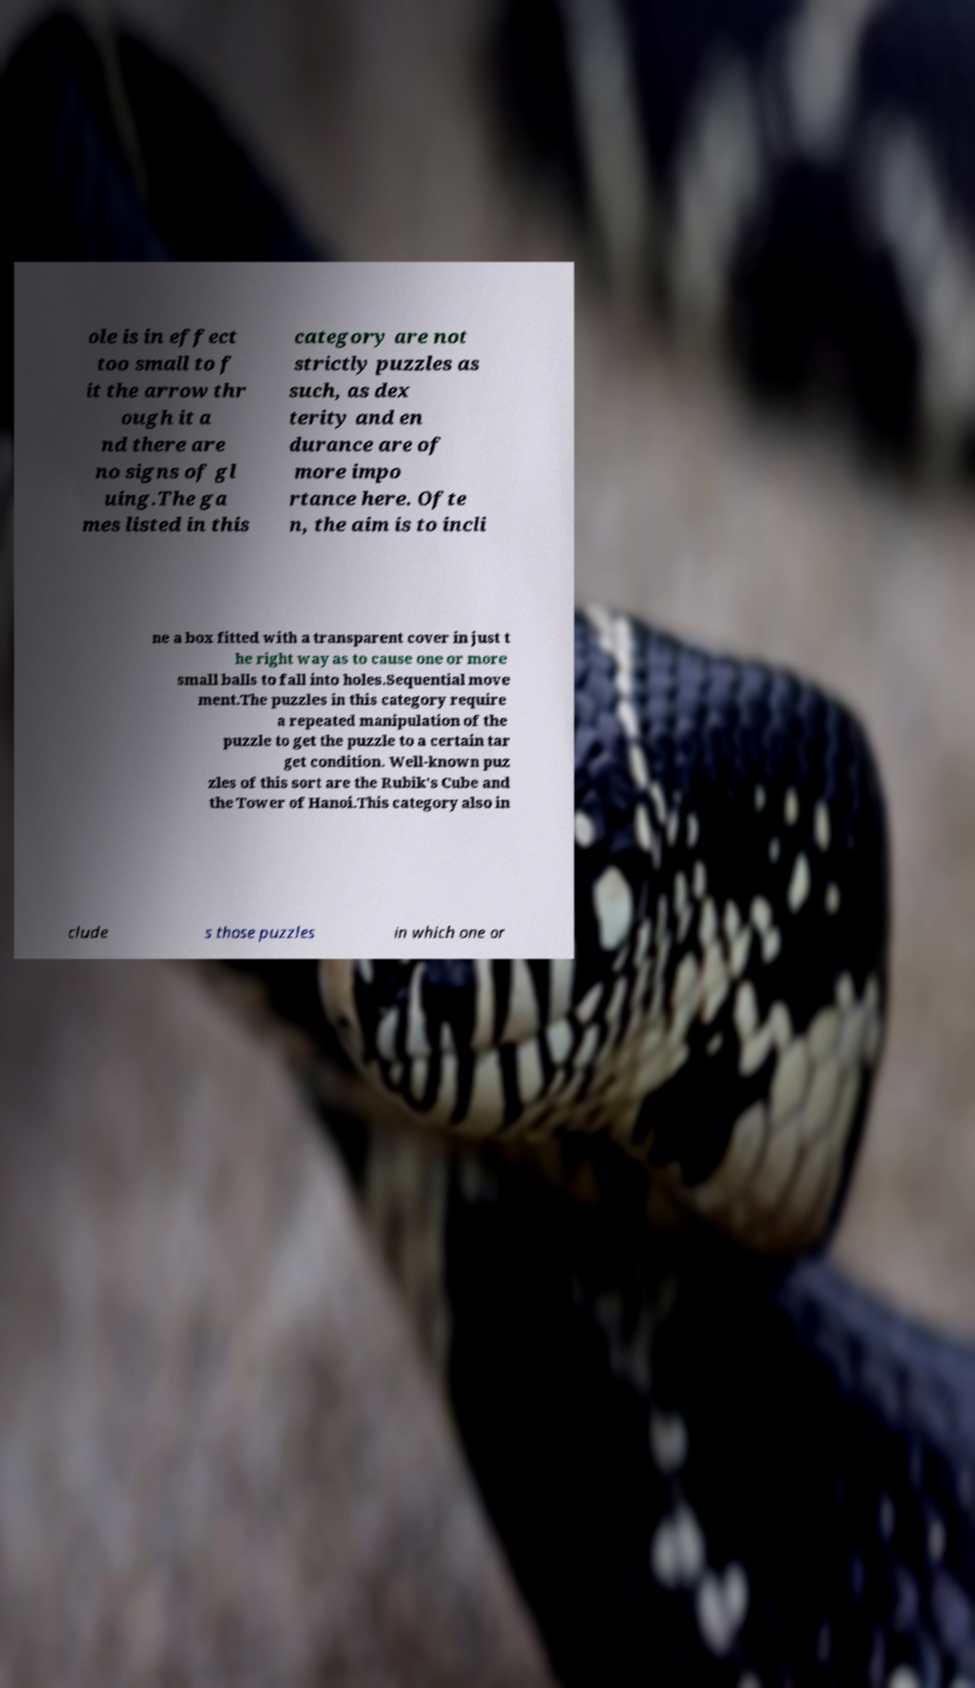Could you assist in decoding the text presented in this image and type it out clearly? ole is in effect too small to f it the arrow thr ough it a nd there are no signs of gl uing.The ga mes listed in this category are not strictly puzzles as such, as dex terity and en durance are of more impo rtance here. Ofte n, the aim is to incli ne a box fitted with a transparent cover in just t he right way as to cause one or more small balls to fall into holes.Sequential move ment.The puzzles in this category require a repeated manipulation of the puzzle to get the puzzle to a certain tar get condition. Well-known puz zles of this sort are the Rubik's Cube and the Tower of Hanoi.This category also in clude s those puzzles in which one or 